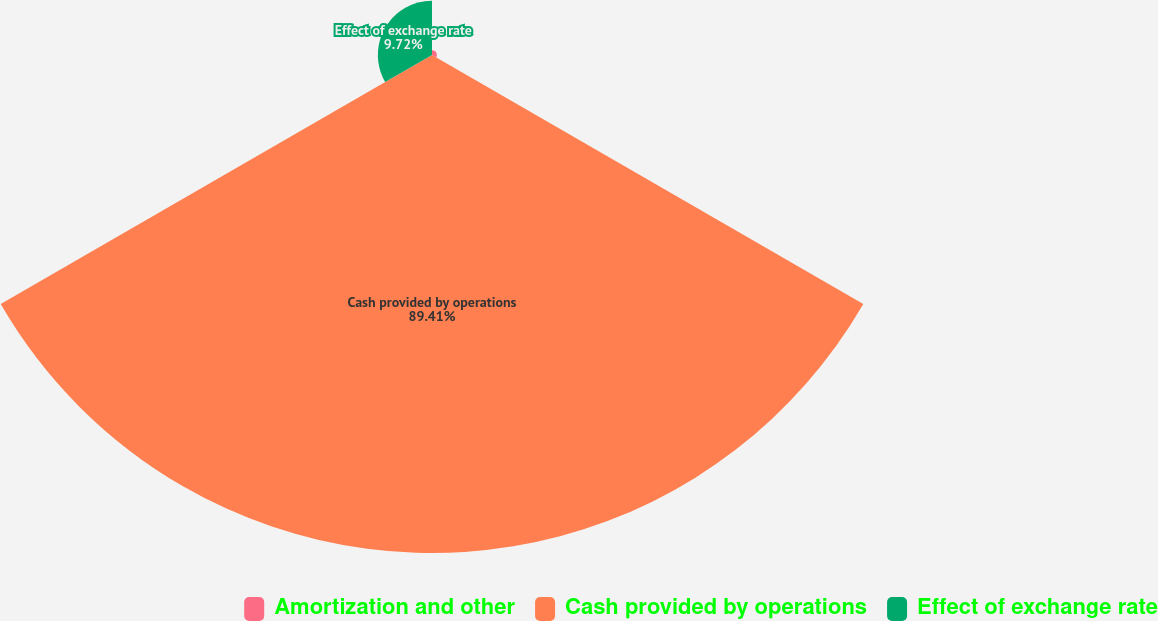Convert chart to OTSL. <chart><loc_0><loc_0><loc_500><loc_500><pie_chart><fcel>Amortization and other<fcel>Cash provided by operations<fcel>Effect of exchange rate<nl><fcel>0.87%<fcel>89.41%<fcel>9.72%<nl></chart> 